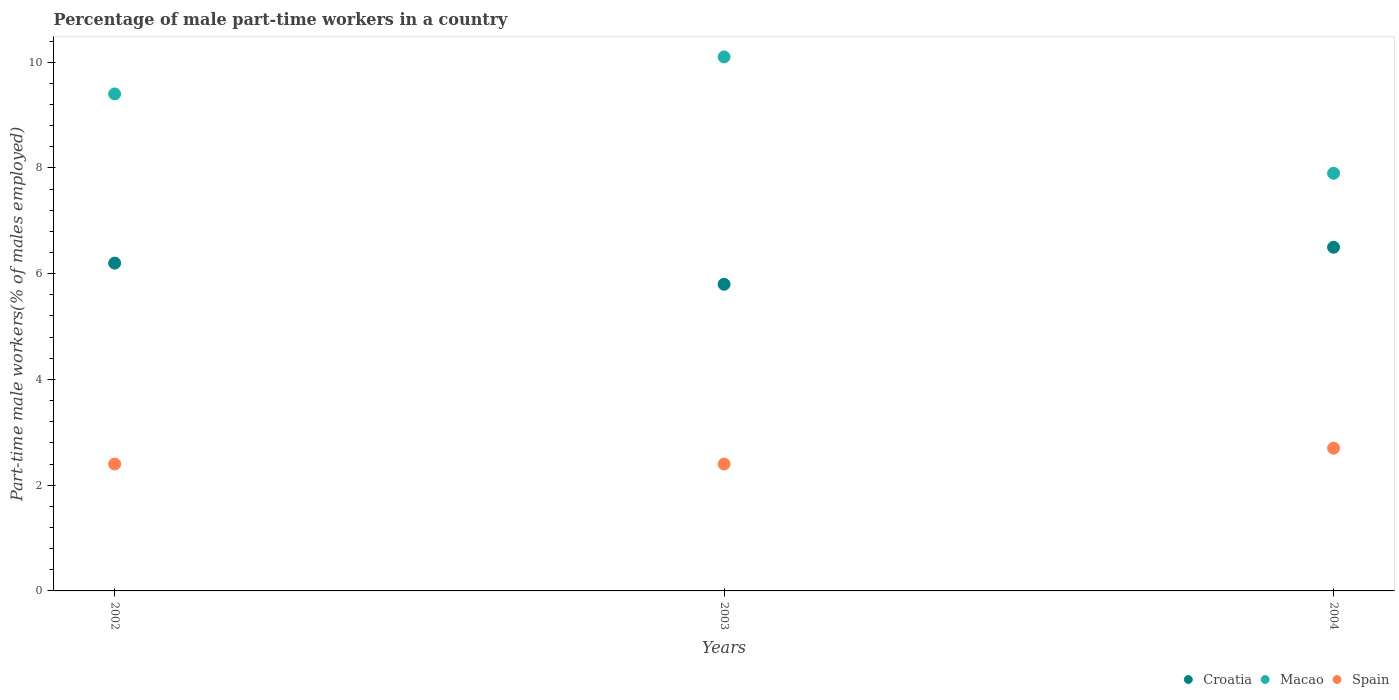How many different coloured dotlines are there?
Offer a terse response. 3. What is the percentage of male part-time workers in Macao in 2004?
Ensure brevity in your answer.  7.9. Across all years, what is the maximum percentage of male part-time workers in Macao?
Your answer should be very brief. 10.1. Across all years, what is the minimum percentage of male part-time workers in Spain?
Your response must be concise. 2.4. In which year was the percentage of male part-time workers in Macao maximum?
Your answer should be very brief. 2003. What is the total percentage of male part-time workers in Macao in the graph?
Your answer should be compact. 27.4. What is the difference between the percentage of male part-time workers in Macao in 2002 and that in 2004?
Keep it short and to the point. 1.5. What is the difference between the percentage of male part-time workers in Croatia in 2004 and the percentage of male part-time workers in Spain in 2003?
Your response must be concise. 4.1. What is the average percentage of male part-time workers in Croatia per year?
Make the answer very short. 6.17. In the year 2004, what is the difference between the percentage of male part-time workers in Croatia and percentage of male part-time workers in Spain?
Offer a very short reply. 3.8. What is the ratio of the percentage of male part-time workers in Macao in 2002 to that in 2003?
Your response must be concise. 0.93. Is the percentage of male part-time workers in Croatia in 2002 less than that in 2004?
Offer a terse response. Yes. Is the difference between the percentage of male part-time workers in Croatia in 2002 and 2004 greater than the difference between the percentage of male part-time workers in Spain in 2002 and 2004?
Offer a very short reply. No. What is the difference between the highest and the second highest percentage of male part-time workers in Macao?
Your response must be concise. 0.7. What is the difference between the highest and the lowest percentage of male part-time workers in Croatia?
Provide a short and direct response. 0.7. In how many years, is the percentage of male part-time workers in Macao greater than the average percentage of male part-time workers in Macao taken over all years?
Your answer should be very brief. 2. Is it the case that in every year, the sum of the percentage of male part-time workers in Macao and percentage of male part-time workers in Croatia  is greater than the percentage of male part-time workers in Spain?
Give a very brief answer. Yes. Does the percentage of male part-time workers in Spain monotonically increase over the years?
Your answer should be very brief. No. Is the percentage of male part-time workers in Croatia strictly less than the percentage of male part-time workers in Macao over the years?
Provide a short and direct response. Yes. How many dotlines are there?
Make the answer very short. 3. How many years are there in the graph?
Offer a terse response. 3. Are the values on the major ticks of Y-axis written in scientific E-notation?
Offer a very short reply. No. Does the graph contain any zero values?
Your response must be concise. No. How many legend labels are there?
Ensure brevity in your answer.  3. How are the legend labels stacked?
Offer a very short reply. Horizontal. What is the title of the graph?
Provide a short and direct response. Percentage of male part-time workers in a country. What is the label or title of the X-axis?
Provide a succinct answer. Years. What is the label or title of the Y-axis?
Make the answer very short. Part-time male workers(% of males employed). What is the Part-time male workers(% of males employed) of Croatia in 2002?
Your answer should be very brief. 6.2. What is the Part-time male workers(% of males employed) in Macao in 2002?
Make the answer very short. 9.4. What is the Part-time male workers(% of males employed) of Spain in 2002?
Provide a short and direct response. 2.4. What is the Part-time male workers(% of males employed) of Croatia in 2003?
Keep it short and to the point. 5.8. What is the Part-time male workers(% of males employed) of Macao in 2003?
Provide a short and direct response. 10.1. What is the Part-time male workers(% of males employed) of Spain in 2003?
Your response must be concise. 2.4. What is the Part-time male workers(% of males employed) of Croatia in 2004?
Ensure brevity in your answer.  6.5. What is the Part-time male workers(% of males employed) of Macao in 2004?
Your answer should be compact. 7.9. What is the Part-time male workers(% of males employed) of Spain in 2004?
Your response must be concise. 2.7. Across all years, what is the maximum Part-time male workers(% of males employed) in Macao?
Provide a short and direct response. 10.1. Across all years, what is the maximum Part-time male workers(% of males employed) of Spain?
Offer a terse response. 2.7. Across all years, what is the minimum Part-time male workers(% of males employed) of Croatia?
Your response must be concise. 5.8. Across all years, what is the minimum Part-time male workers(% of males employed) of Macao?
Provide a succinct answer. 7.9. Across all years, what is the minimum Part-time male workers(% of males employed) in Spain?
Provide a short and direct response. 2.4. What is the total Part-time male workers(% of males employed) in Croatia in the graph?
Your answer should be compact. 18.5. What is the total Part-time male workers(% of males employed) in Macao in the graph?
Make the answer very short. 27.4. What is the difference between the Part-time male workers(% of males employed) in Croatia in 2002 and that in 2003?
Offer a very short reply. 0.4. What is the difference between the Part-time male workers(% of males employed) in Macao in 2002 and that in 2003?
Provide a short and direct response. -0.7. What is the difference between the Part-time male workers(% of males employed) of Spain in 2002 and that in 2003?
Make the answer very short. 0. What is the difference between the Part-time male workers(% of males employed) of Croatia in 2002 and that in 2004?
Offer a terse response. -0.3. What is the difference between the Part-time male workers(% of males employed) in Spain in 2002 and that in 2004?
Provide a short and direct response. -0.3. What is the difference between the Part-time male workers(% of males employed) in Spain in 2003 and that in 2004?
Make the answer very short. -0.3. What is the difference between the Part-time male workers(% of males employed) of Croatia in 2002 and the Part-time male workers(% of males employed) of Macao in 2003?
Provide a short and direct response. -3.9. What is the difference between the Part-time male workers(% of males employed) in Croatia in 2002 and the Part-time male workers(% of males employed) in Spain in 2003?
Provide a short and direct response. 3.8. What is the difference between the Part-time male workers(% of males employed) in Macao in 2002 and the Part-time male workers(% of males employed) in Spain in 2003?
Provide a short and direct response. 7. What is the difference between the Part-time male workers(% of males employed) in Croatia in 2002 and the Part-time male workers(% of males employed) in Macao in 2004?
Keep it short and to the point. -1.7. What is the difference between the Part-time male workers(% of males employed) of Croatia in 2002 and the Part-time male workers(% of males employed) of Spain in 2004?
Your answer should be compact. 3.5. What is the difference between the Part-time male workers(% of males employed) in Macao in 2002 and the Part-time male workers(% of males employed) in Spain in 2004?
Your response must be concise. 6.7. What is the difference between the Part-time male workers(% of males employed) in Croatia in 2003 and the Part-time male workers(% of males employed) in Spain in 2004?
Offer a very short reply. 3.1. What is the average Part-time male workers(% of males employed) of Croatia per year?
Provide a short and direct response. 6.17. What is the average Part-time male workers(% of males employed) in Macao per year?
Your answer should be compact. 9.13. What is the average Part-time male workers(% of males employed) in Spain per year?
Ensure brevity in your answer.  2.5. In the year 2003, what is the difference between the Part-time male workers(% of males employed) of Croatia and Part-time male workers(% of males employed) of Macao?
Make the answer very short. -4.3. In the year 2003, what is the difference between the Part-time male workers(% of males employed) in Croatia and Part-time male workers(% of males employed) in Spain?
Provide a succinct answer. 3.4. In the year 2003, what is the difference between the Part-time male workers(% of males employed) in Macao and Part-time male workers(% of males employed) in Spain?
Your response must be concise. 7.7. In the year 2004, what is the difference between the Part-time male workers(% of males employed) of Croatia and Part-time male workers(% of males employed) of Macao?
Your answer should be very brief. -1.4. In the year 2004, what is the difference between the Part-time male workers(% of males employed) of Macao and Part-time male workers(% of males employed) of Spain?
Keep it short and to the point. 5.2. What is the ratio of the Part-time male workers(% of males employed) in Croatia in 2002 to that in 2003?
Make the answer very short. 1.07. What is the ratio of the Part-time male workers(% of males employed) in Macao in 2002 to that in 2003?
Your response must be concise. 0.93. What is the ratio of the Part-time male workers(% of males employed) in Spain in 2002 to that in 2003?
Offer a very short reply. 1. What is the ratio of the Part-time male workers(% of males employed) in Croatia in 2002 to that in 2004?
Keep it short and to the point. 0.95. What is the ratio of the Part-time male workers(% of males employed) of Macao in 2002 to that in 2004?
Offer a terse response. 1.19. What is the ratio of the Part-time male workers(% of males employed) in Spain in 2002 to that in 2004?
Make the answer very short. 0.89. What is the ratio of the Part-time male workers(% of males employed) in Croatia in 2003 to that in 2004?
Your answer should be very brief. 0.89. What is the ratio of the Part-time male workers(% of males employed) in Macao in 2003 to that in 2004?
Offer a terse response. 1.28. What is the ratio of the Part-time male workers(% of males employed) in Spain in 2003 to that in 2004?
Keep it short and to the point. 0.89. What is the difference between the highest and the second highest Part-time male workers(% of males employed) of Macao?
Offer a very short reply. 0.7. What is the difference between the highest and the second highest Part-time male workers(% of males employed) in Spain?
Offer a terse response. 0.3. 